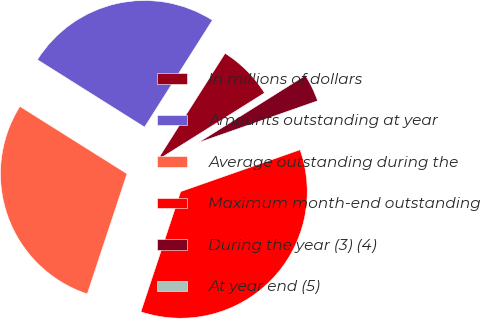Convert chart to OTSL. <chart><loc_0><loc_0><loc_500><loc_500><pie_chart><fcel>In millions of dollars<fcel>Amounts outstanding at year<fcel>Average outstanding during the<fcel>Maximum month-end outstanding<fcel>During the year (3) (4)<fcel>At year end (5)<nl><fcel>7.09%<fcel>25.06%<fcel>28.85%<fcel>35.45%<fcel>3.55%<fcel>0.0%<nl></chart> 